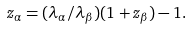<formula> <loc_0><loc_0><loc_500><loc_500>z _ { \alpha } = ( \lambda _ { \alpha } / \lambda _ { \beta } ) ( 1 + z _ { \beta } ) - 1 .</formula> 